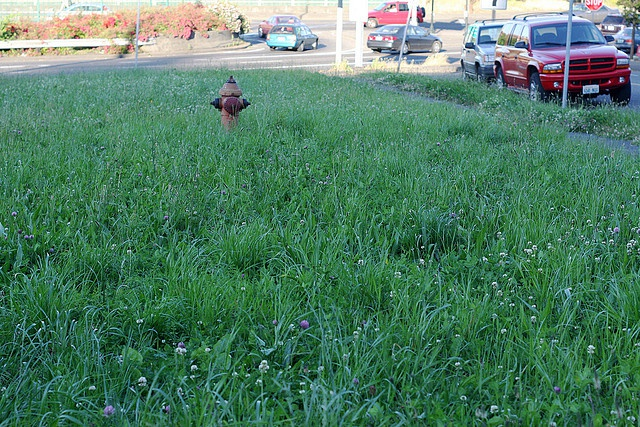Describe the objects in this image and their specific colors. I can see car in white, black, lavender, and maroon tones, car in white, darkgray, lightgray, and gray tones, car in white, lightgray, lightblue, and darkgray tones, car in white, lightblue, and darkgray tones, and fire hydrant in white, gray, and black tones in this image. 